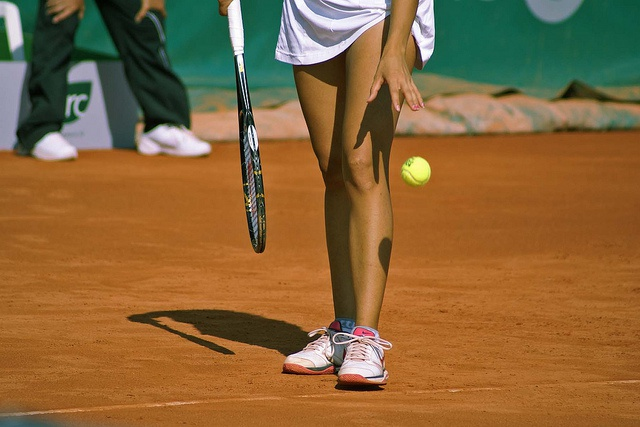Describe the objects in this image and their specific colors. I can see people in green, olive, black, lavender, and maroon tones, people in green, black, lavender, teal, and darkgreen tones, tennis racket in green, black, white, gray, and olive tones, and sports ball in green, khaki, and olive tones in this image. 